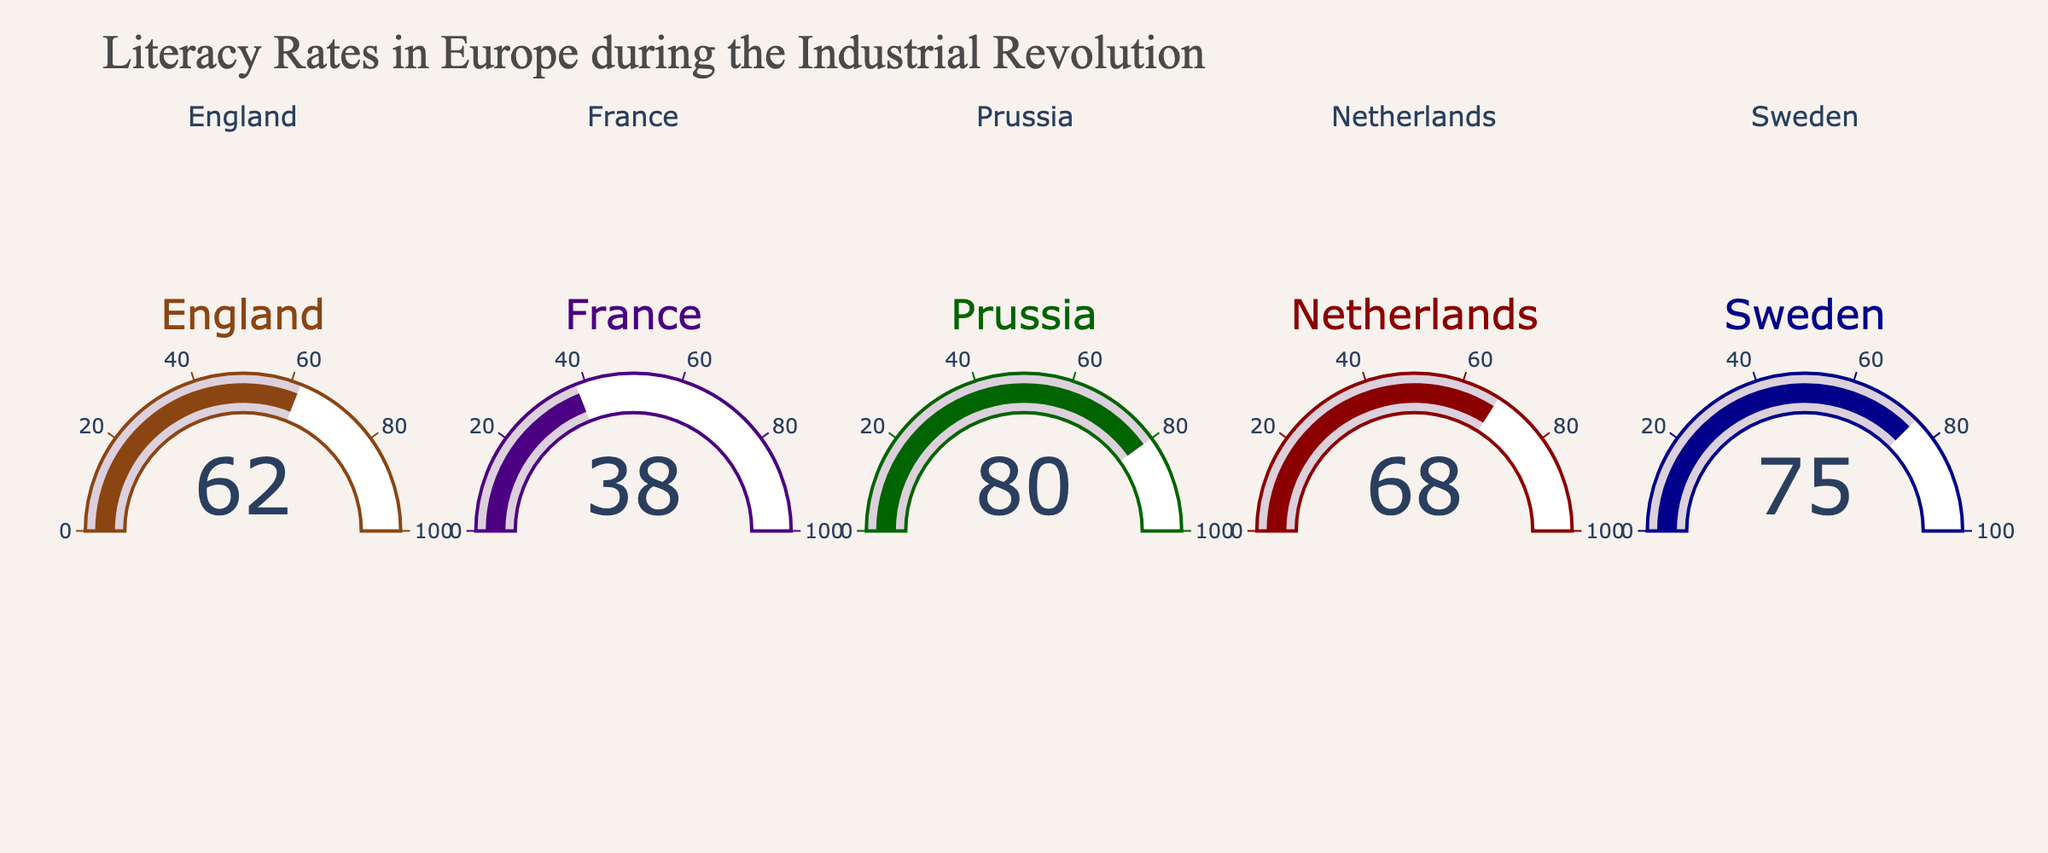What is the literacy rate of France? The literacy rate can be read directly from the gauge chart for France.
Answer: 38 Which country has the highest literacy rate? By comparing the values on each gauge, the country with the highest literacy rate is Prussia.
Answer: Prussia What's the average literacy rate across all five countries? Sum the literacy rates of all five countries and divide by the number of countries: (62 + 38 + 80 + 68 + 75) / 5 = 323 / 5.
Answer: 64.6 How many countries have a literacy rate above 60%? Identify the countries with literacy rates above 60%: England (62), Prussia (80), Netherlands (68), and Sweden (75). There are four such countries.
Answer: 4 Which country has the lowest literacy rate? By comparing the values on each gauge, the country with the lowest literacy rate is France.
Answer: France What is the difference in literacy rates between the Netherlands and Sweden? Subtract the literacy rate of the Netherlands from that of Sweden: 75 - 68.
Answer: 7 What color is used for the gauge of England? The gauge for England is brown in color.
Answer: Brown Is the literacy rate of France greater than that of Netherlands? Compare the literacy rates: France (38) vs Netherlands (68). France's literacy rate is not greater.
Answer: No If the literacy rates were to increase by 10% for each country, what would be the new literacy rate for Prussia? Add 10% to Prussia's current rate: 80 + (80 * 0.10) = 80 + 8.
Answer: 88 